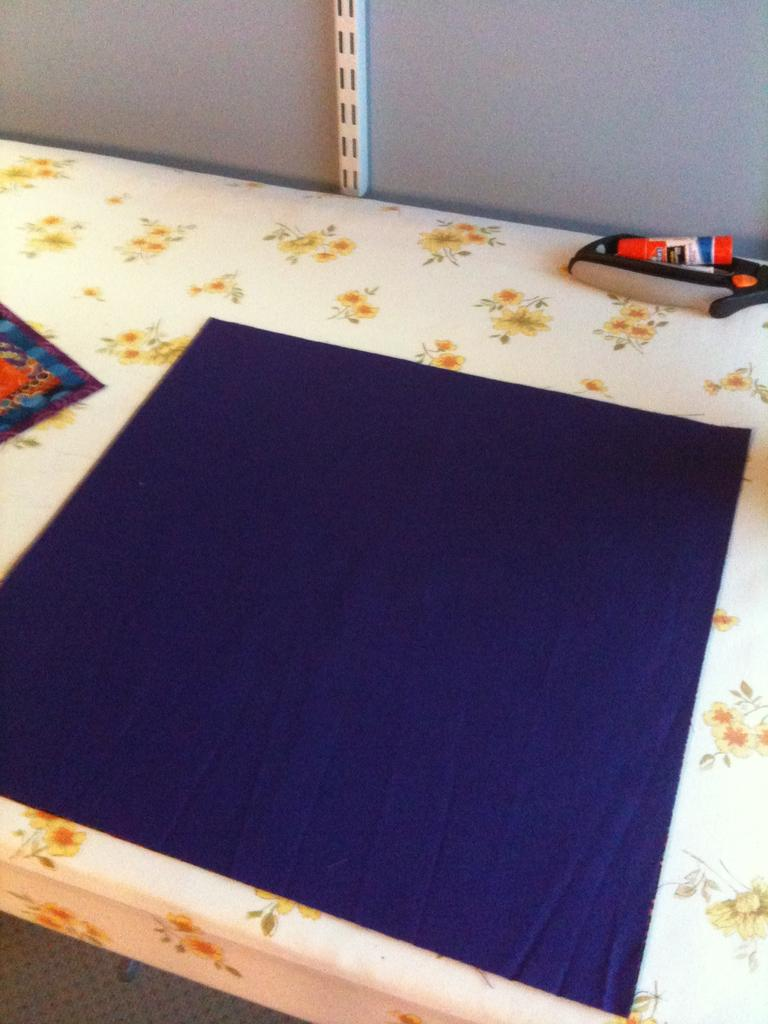What is covering the table in the image? There is a table with a floral cloth in the image. What color is the cloth on the table? There is a blue cloth on the table. What can be found on the table? There are items on the table. What is visible behind the table? There is a wall behind the table. What is hanging on the wall? There is an object on the wall. What type of juice is being squeezed from the stick in the image? There is no stick or juice present in the image. Is there a hen sitting on the table in the image? There is no hen present in the image. 